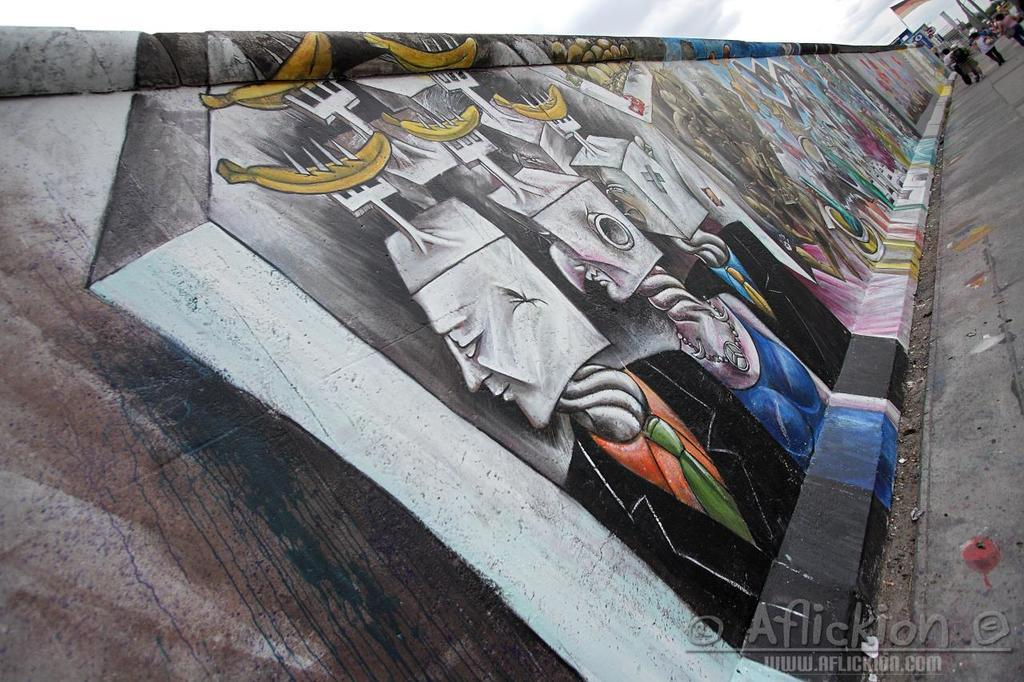What is on the wall in the image? There is a painting on the wall. What can be seen in the background of the image? There are people and poles in the background of the image, as well as the sky. What is the purpose of the poles in the background? The purpose of the poles is not specified in the image, but they could be for support or decoration. Where is the watermark located in the image? The watermark is in the bottom right side of the image. What type of juice is being served to the people in the image? There is no juice or indication of a beverage being served in the image. Is there a door visible in the image? No, there is no door visible in the image. 